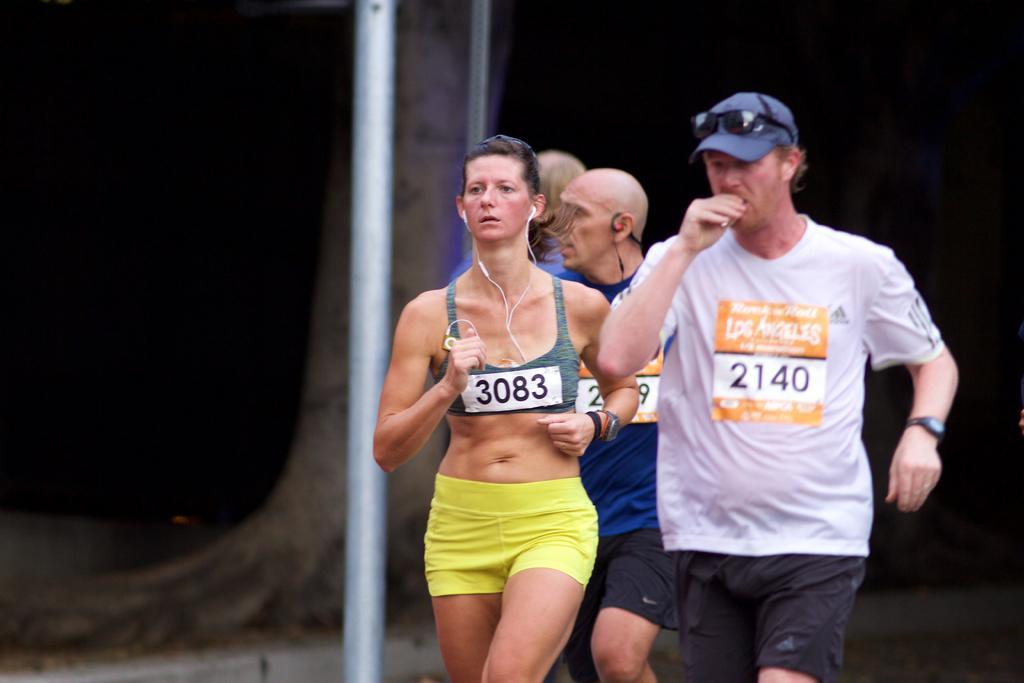Could you give a brief overview of what you see in this image? In this image I see 4 persons and I see the white pole over here and in the background I see a tree over here and I see that it is dark. 